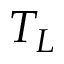Convert formula to latex. <formula><loc_0><loc_0><loc_500><loc_500>T _ { L }</formula> 